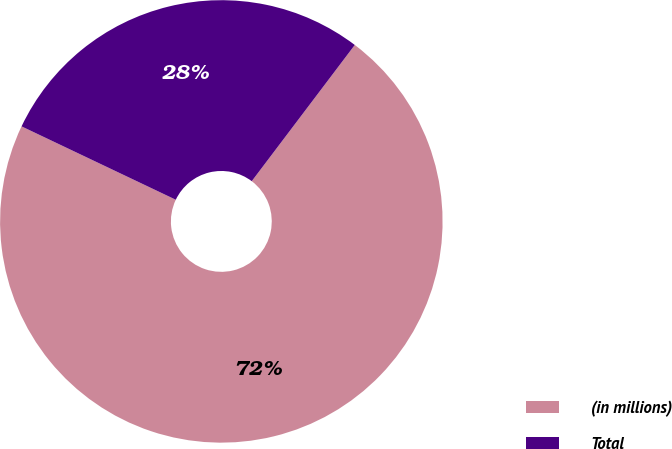Convert chart to OTSL. <chart><loc_0><loc_0><loc_500><loc_500><pie_chart><fcel>(in millions)<fcel>Total<nl><fcel>71.76%<fcel>28.24%<nl></chart> 